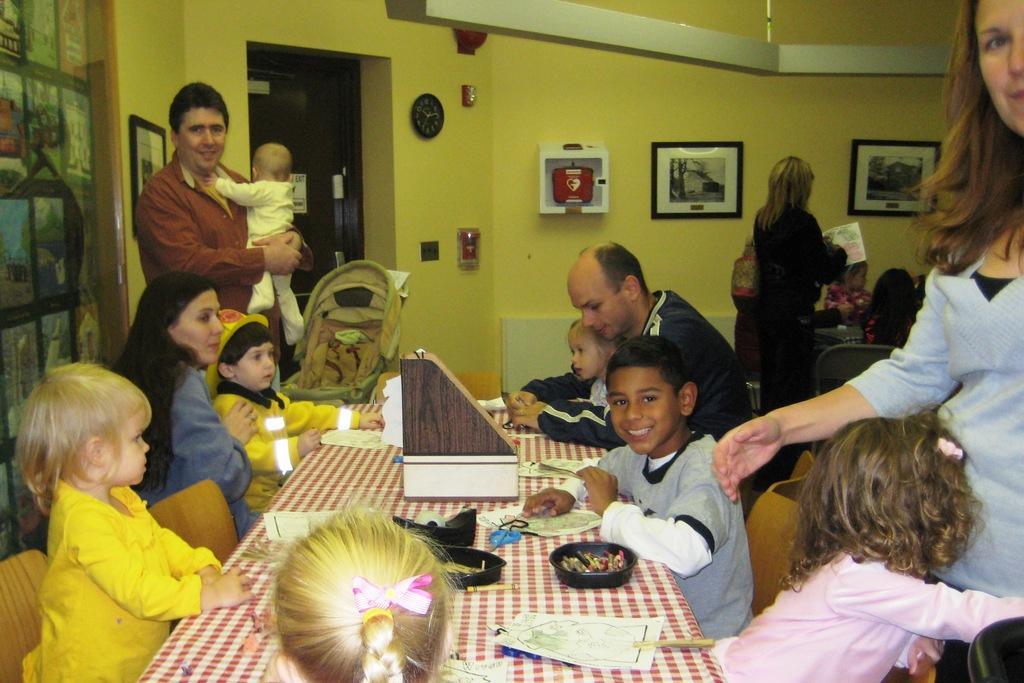Describe this image in one or two sentences. In this image there are a few people sitting and few are standing. In the middle of them there is a table with some papers, balls and a few other objects, there is a person holding a baby, beside him there is a baby walker, there are a few frames and objects are hanging on the wall. 